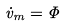Convert formula to latex. <formula><loc_0><loc_0><loc_500><loc_500>\dot { v } _ { m } = \Phi</formula> 